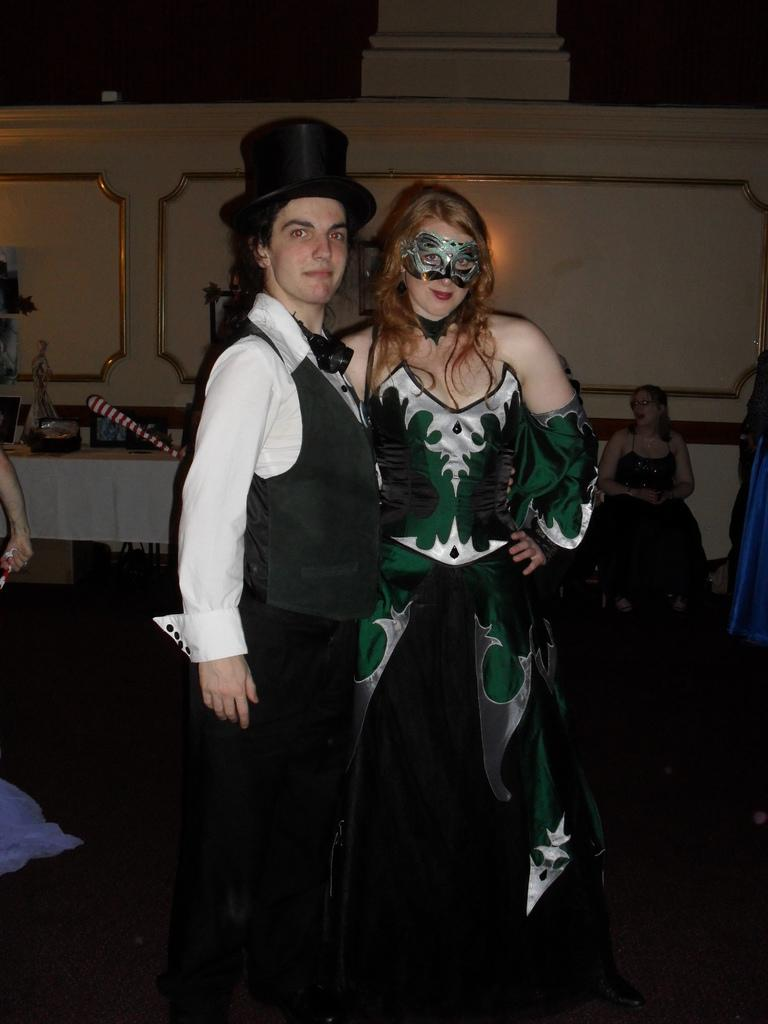What are the two persons in the image doing? The two persons in the image are standing and smiling. What can be seen in the background of the image? There is a group of people and objects on a table in the background of the image. What is the wall visible in the background of the image made of? The facts provided do not specify the material of the wall. How many people are visible in the image? There are at least two persons (the two standing and smiling) and a group of people in the background, so there are more than two people visible in the image. What type of substance is the hot look emanating from in the image? There is no mention of a "hot look" in the image, so this question cannot be answered based on the provided facts. 